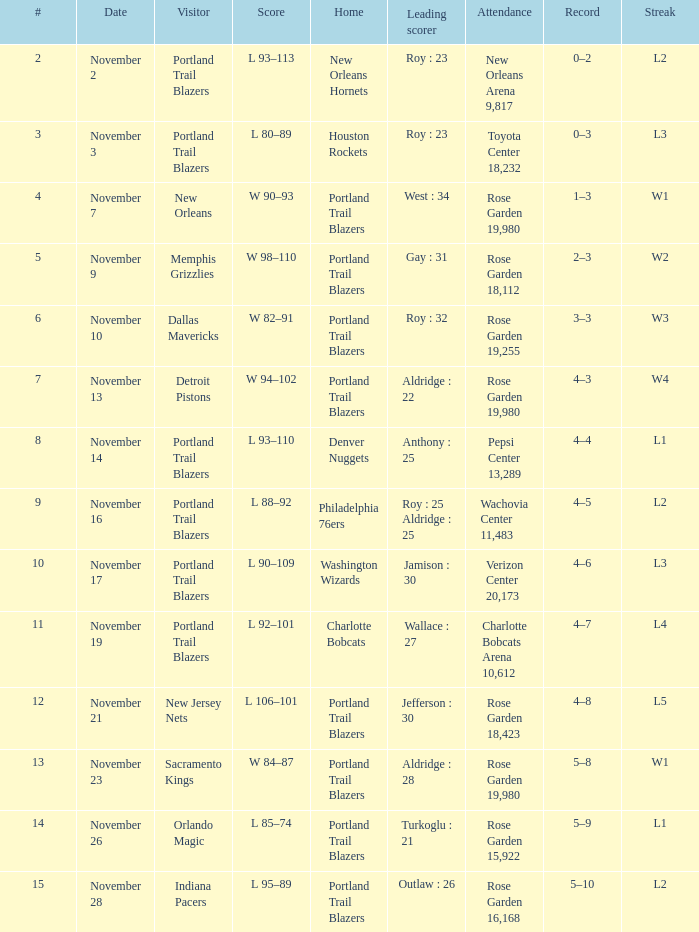What is the overall count of records where streak is l2 and top scorer is roy: 23? 1.0. 